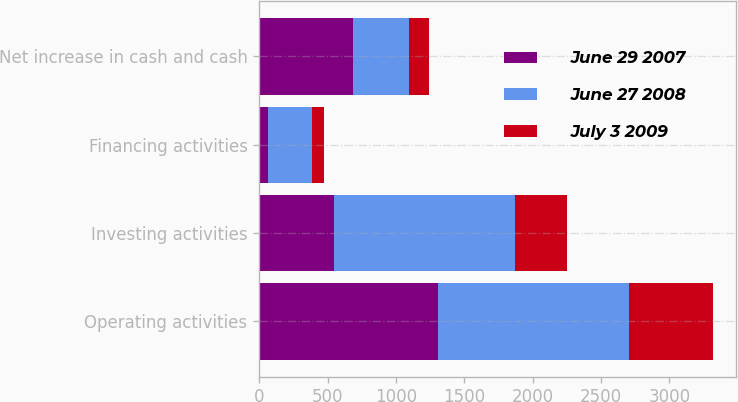Convert chart. <chart><loc_0><loc_0><loc_500><loc_500><stacked_bar_chart><ecel><fcel>Operating activities<fcel>Investing activities<fcel>Financing activities<fcel>Net increase in cash and cash<nl><fcel>June 29 2007<fcel>1305<fcel>551<fcel>64<fcel>690<nl><fcel>June 27 2008<fcel>1399<fcel>1321<fcel>326<fcel>404<nl><fcel>July 3 2009<fcel>618<fcel>383<fcel>86<fcel>149<nl></chart> 